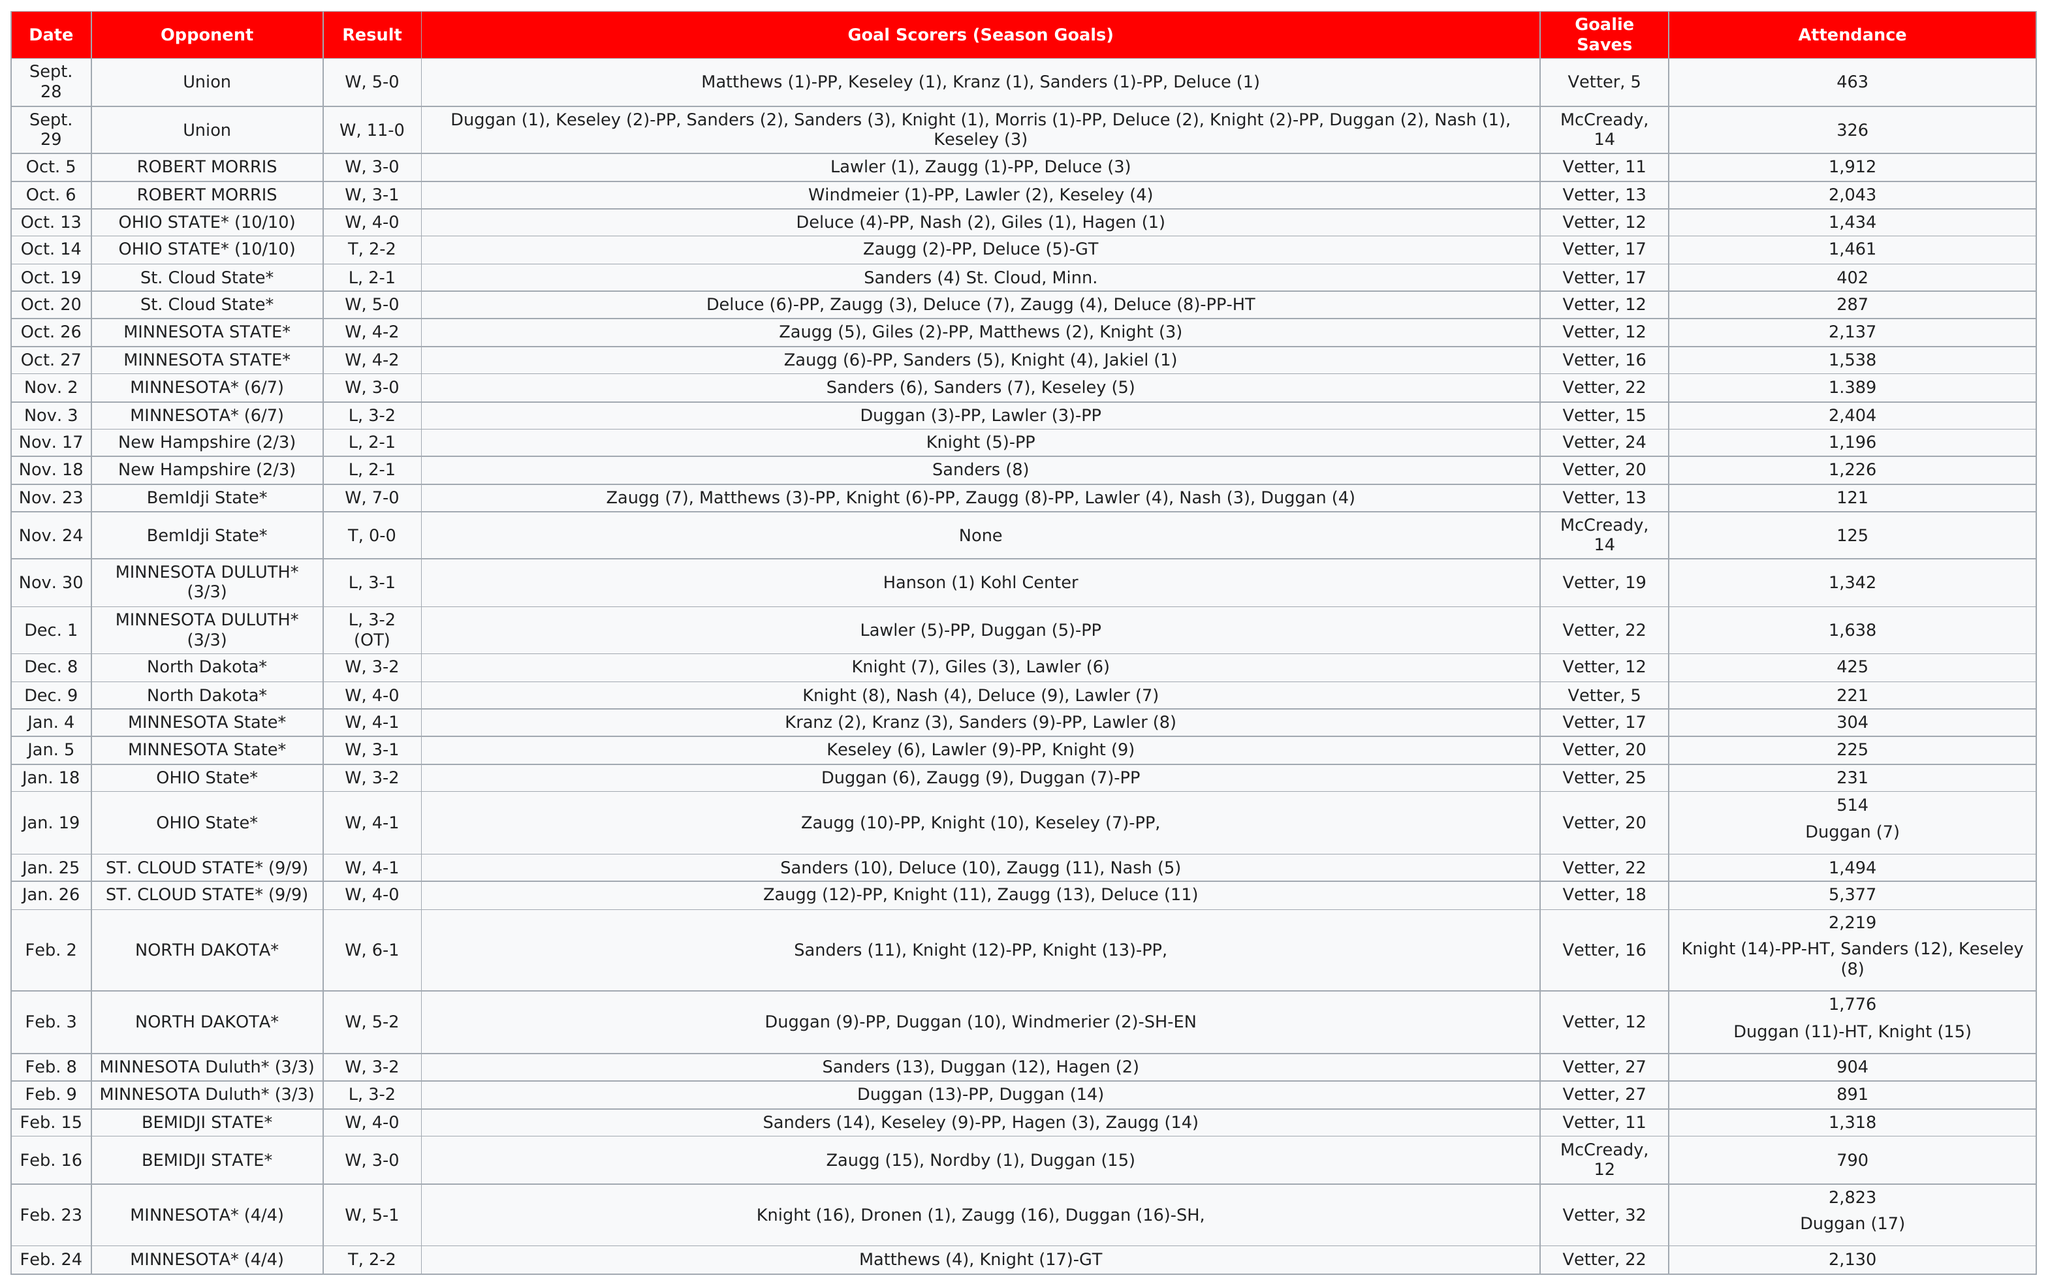List a handful of essential elements in this visual. The goalie who had the most saves was Vetter. The University of Wisconsin-Madison Badgers football team faced Union College in their first game of the season. On January 26th, the highest attendance was recorded. The Wisconsin Badgers women's ice hockey team has suffered a total of 7 losses. In how many games did at least 1500 people attend, and the answer is 11. 